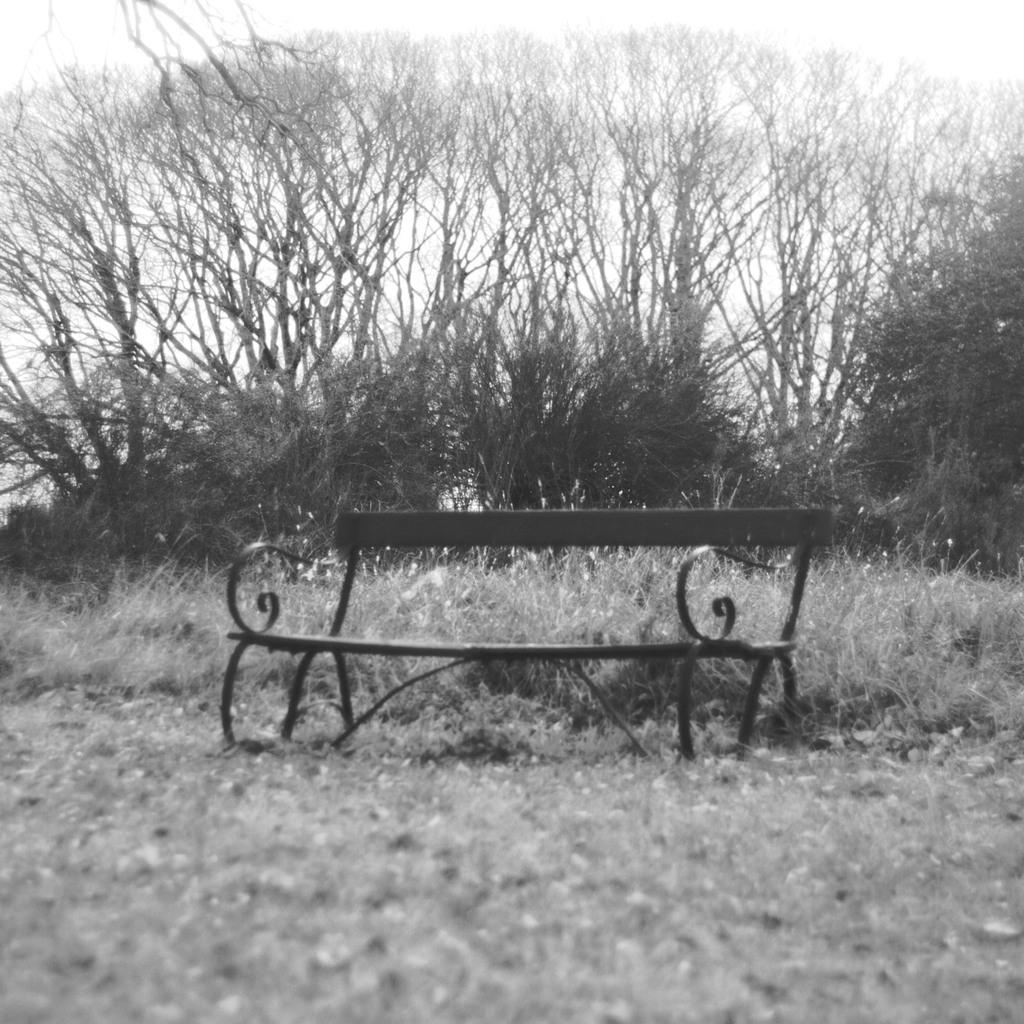What type of vegetation can be seen in the image? There are trees in the image. What part of the natural environment is visible in the image? The sky is visible in the image. What type of ground cover is present in the image? There is grass in the image. What type of seating is visible in the foreground of the image? A bench is visible in the foreground of the image. What type of leather material is used to make the faucet in the image? There is no faucet present in the image. Can you describe the appearance of the grandfather in the image? There is no person, let alone a grandfather, present in the image. 